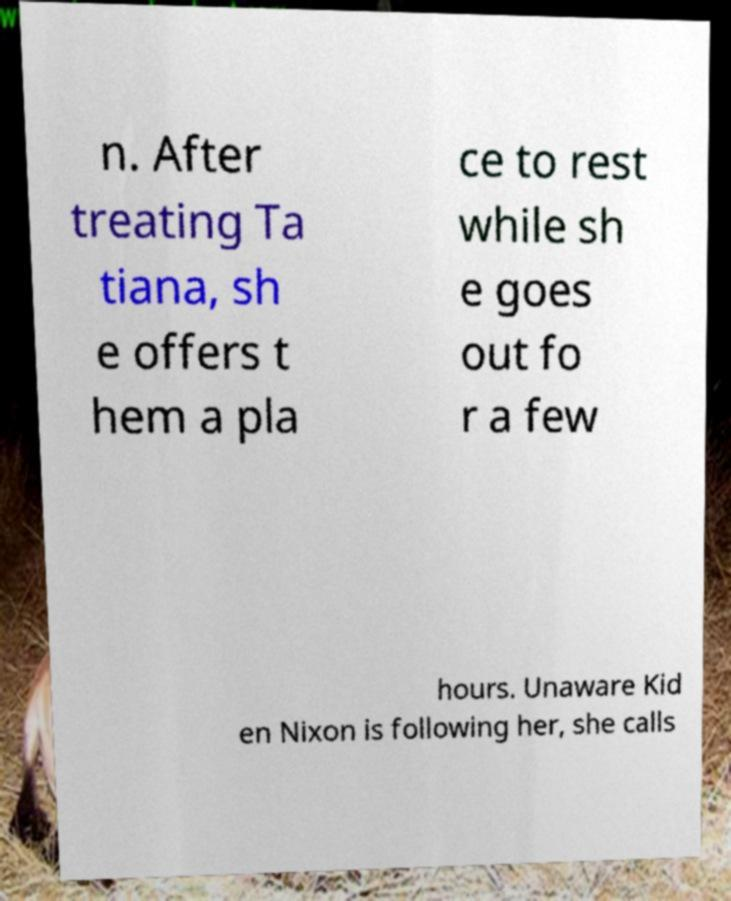For documentation purposes, I need the text within this image transcribed. Could you provide that? n. After treating Ta tiana, sh e offers t hem a pla ce to rest while sh e goes out fo r a few hours. Unaware Kid en Nixon is following her, she calls 